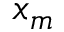Convert formula to latex. <formula><loc_0><loc_0><loc_500><loc_500>x _ { m }</formula> 